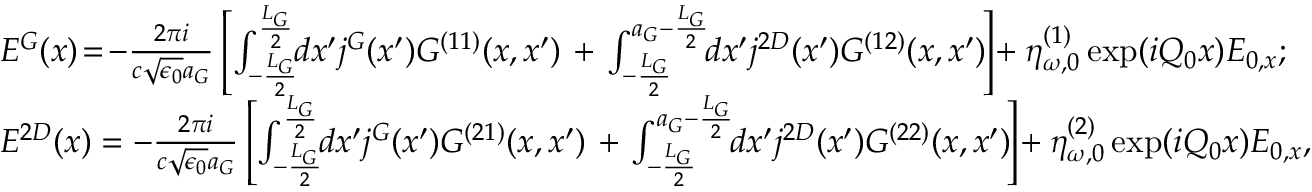<formula> <loc_0><loc_0><loc_500><loc_500>\begin{array} { r l } & { E ^ { G } ( x ) \, = \, - \frac { 2 \pi i } { c \sqrt { \epsilon _ { 0 } } a _ { G } } \left [ \int _ { - \frac { L _ { G } } { 2 } } ^ { \frac { L _ { G } } { 2 } } \, d x ^ { \prime } j ^ { G } ( x ^ { \prime } ) G ^ { ( 1 1 ) } ( x , x ^ { \prime } ) + \int _ { - \frac { L _ { G } } { 2 } } ^ { a _ { G } - \frac { L _ { G } } { 2 } } \, d x ^ { \prime } j ^ { 2 D } ( x ^ { \prime } ) G ^ { ( 1 2 ) } ( x , x ^ { \prime } ) \, \right ] \, + \eta _ { \omega , 0 } ^ { ( 1 ) } \exp ( i Q _ { 0 } x ) E _ { 0 , x } ; } \\ & { E ^ { 2 D } ( x ) = - \frac { 2 \pi i } { c \sqrt { \epsilon _ { 0 } } a _ { G } } \left [ \int _ { - \frac { L _ { G } } { 2 } } ^ { \frac { L _ { G } } { 2 } } \, d x ^ { \prime } j ^ { G } ( x ^ { \prime } ) G ^ { ( 2 1 ) } ( x , x ^ { \prime } ) + \int _ { - \frac { L _ { G } } { 2 } } ^ { a _ { G } - \frac { L _ { G } } { 2 } } \, d x ^ { \prime } j ^ { 2 D } ( x ^ { \prime } ) G ^ { ( 2 2 ) } ( x , x ^ { \prime } ) \, \right ] \, + \eta _ { \omega , 0 } ^ { ( 2 ) } \exp ( i Q _ { 0 } x ) E _ { 0 , x } , } \end{array}</formula> 